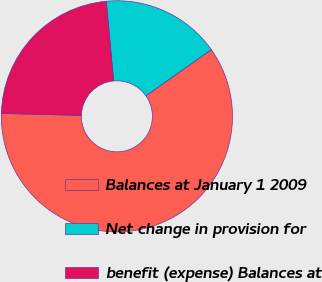<chart> <loc_0><loc_0><loc_500><loc_500><pie_chart><fcel>Balances at January 1 2009<fcel>Net change in provision for<fcel>benefit (expense) Balances at<nl><fcel>60.19%<fcel>16.67%<fcel>23.14%<nl></chart> 